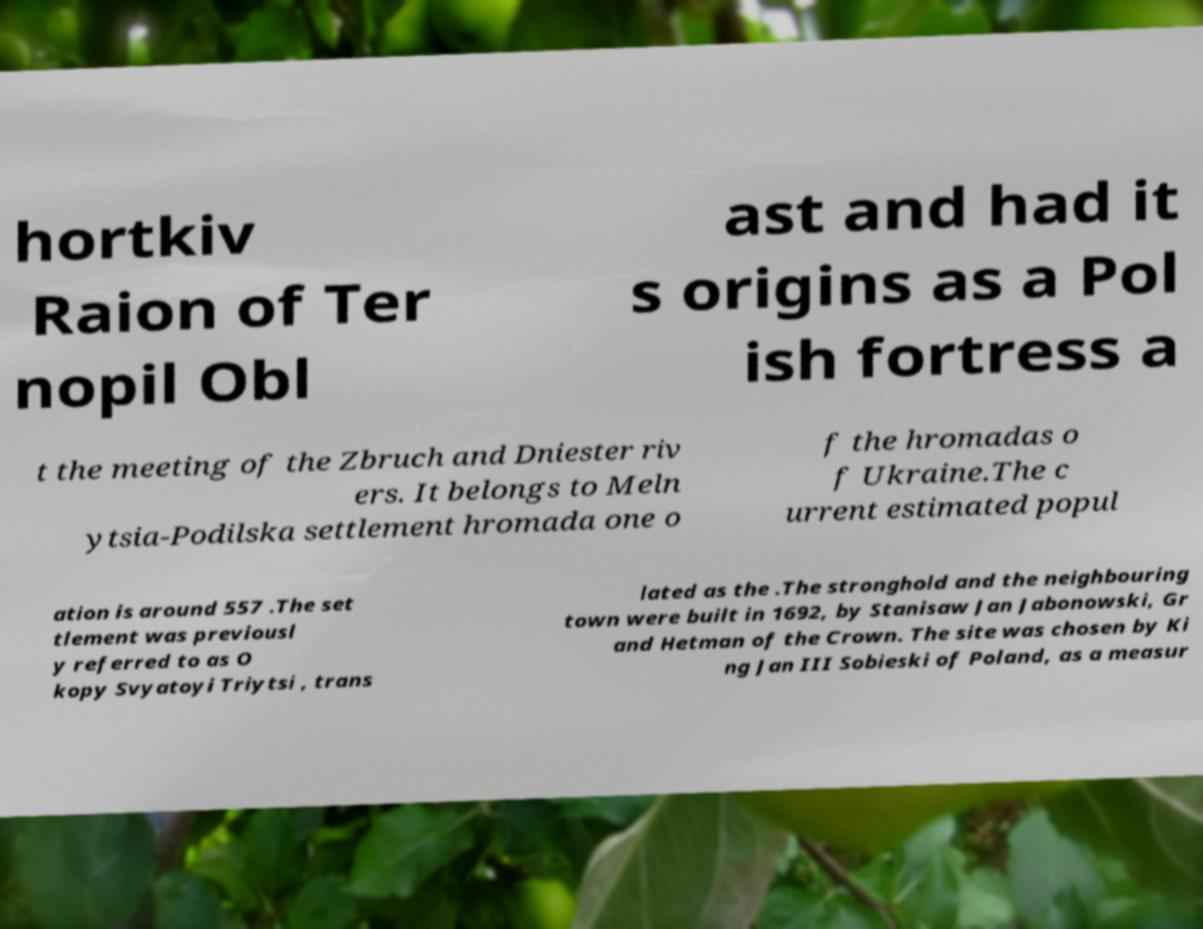Could you assist in decoding the text presented in this image and type it out clearly? hortkiv Raion of Ter nopil Obl ast and had it s origins as a Pol ish fortress a t the meeting of the Zbruch and Dniester riv ers. It belongs to Meln ytsia-Podilska settlement hromada one o f the hromadas o f Ukraine.The c urrent estimated popul ation is around 557 .The set tlement was previousl y referred to as O kopy Svyatoyi Triytsi , trans lated as the .The stronghold and the neighbouring town were built in 1692, by Stanisaw Jan Jabonowski, Gr and Hetman of the Crown. The site was chosen by Ki ng Jan III Sobieski of Poland, as a measur 